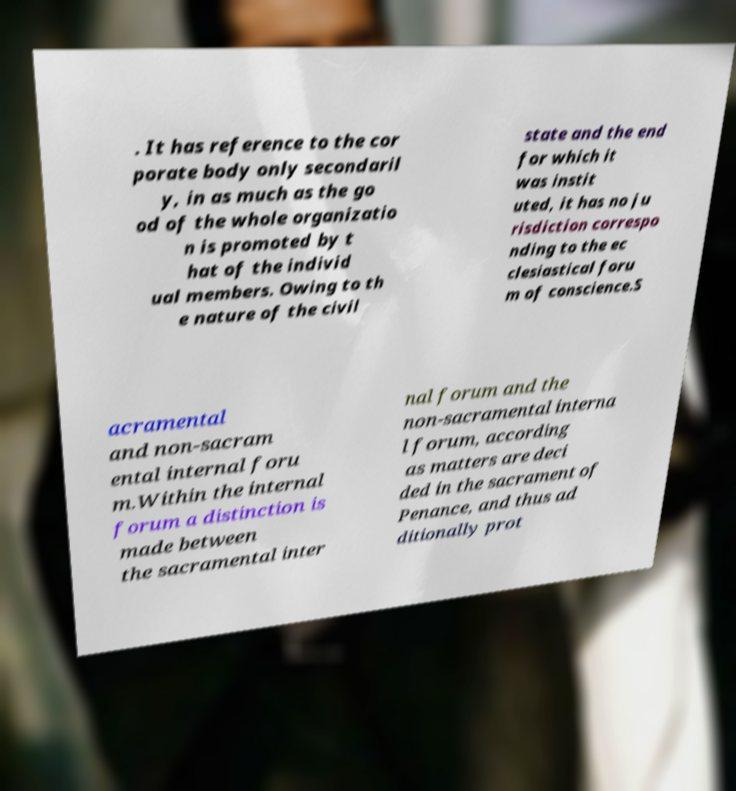Could you extract and type out the text from this image? . It has reference to the cor porate body only secondaril y, in as much as the go od of the whole organizatio n is promoted by t hat of the individ ual members. Owing to th e nature of the civil state and the end for which it was instit uted, it has no ju risdiction correspo nding to the ec clesiastical foru m of conscience.S acramental and non-sacram ental internal foru m.Within the internal forum a distinction is made between the sacramental inter nal forum and the non-sacramental interna l forum, according as matters are deci ded in the sacrament of Penance, and thus ad ditionally prot 